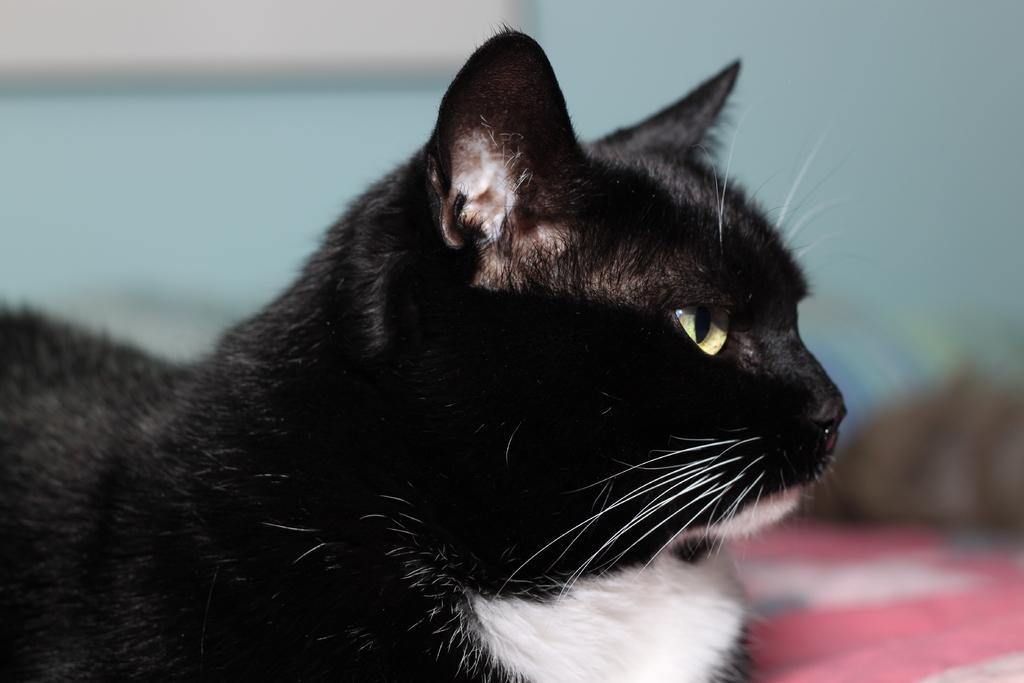How would you summarize this image in a sentence or two? In this image we can see a cat which is of black and white color and the background is blurry. 